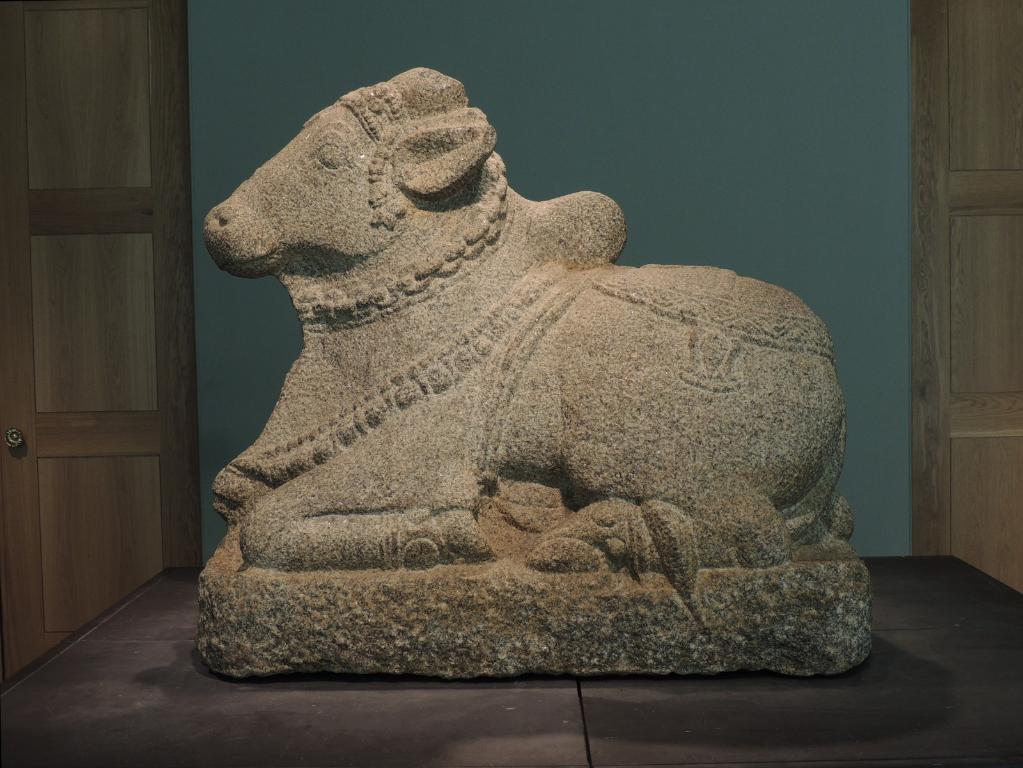Can you describe this image briefly? In this image in the center there is one sculpture and in the background there is a wall and doors, at the bottom there is table. 